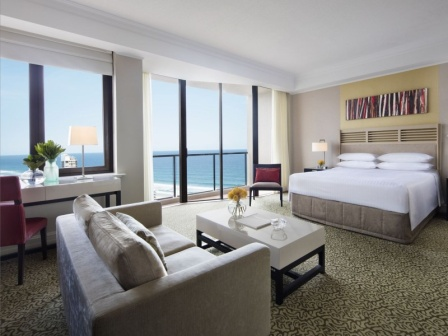Can you describe the main features of this image for me? The image showcases a well-appointed hotel room with a breathtaking ocean view. Center stage is a large bed with inviting white linens and a contrasting grey headboard, positioned perfectly for enjoying the seascape. A striking piece of modern art hangs above the bed, adding a pop of color to the space. Facing the bed is a plush grey sofa set beside a sleek white coffee table, making it an ideal spot for relaxation. The room's ambiance is enhanced by the natural light streaming in through expansive windows, casting a warm glow on the patterned carpet. This peaceful retreat harmoniously blends comfort with a chic aesthetic, captured in its choice of furniture and color scheme. 